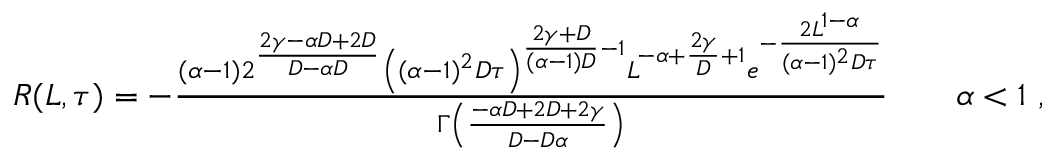<formula> <loc_0><loc_0><loc_500><loc_500>\begin{array} { r } { R ( L , \tau ) = - \frac { ( \alpha - 1 ) 2 ^ { \frac { 2 \gamma - \alpha D + 2 D } { D - \alpha D } } \left ( ( \alpha - 1 ) ^ { 2 } D \tau \right ) ^ { \frac { 2 \gamma + D } { ( \alpha - 1 ) D } - 1 } L ^ { - \alpha + \frac { 2 \gamma } { D } + 1 } e ^ { - \frac { 2 L ^ { 1 - \alpha } } { ( \alpha - 1 ) ^ { 2 } D \tau } } } { \Gamma \left ( \frac { - \alpha D + 2 D + 2 \gamma } { D - D \alpha } \right ) } \quad \alpha < 1 \ , } \end{array}</formula> 